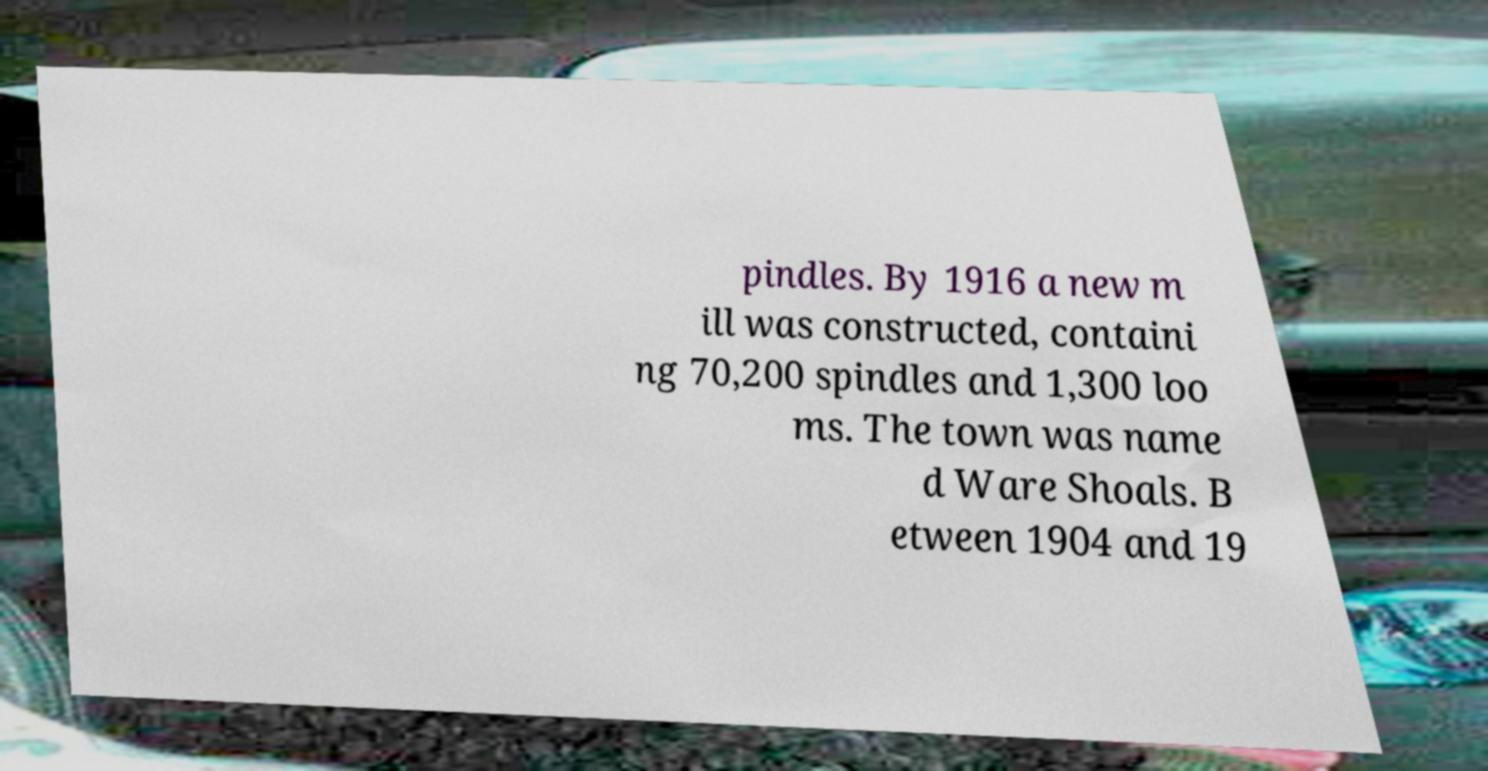There's text embedded in this image that I need extracted. Can you transcribe it verbatim? pindles. By 1916 a new m ill was constructed, containi ng 70,200 spindles and 1,300 loo ms. The town was name d Ware Shoals. B etween 1904 and 19 